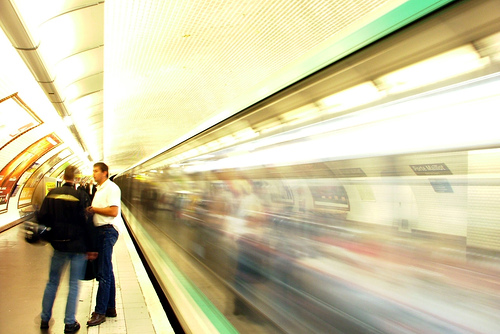Is the image of average quality? The image appears to have been taken with a slow shutter speed, resulting in motion blur, particularly noticeable on the moving train. This technique can be artistically valuable, but it might not represent 'average quality' for those who prefer clear and sharp images. Therefore, the quality of the image can be seen as a creative choice rather than an indicator of average technical proficiency. 